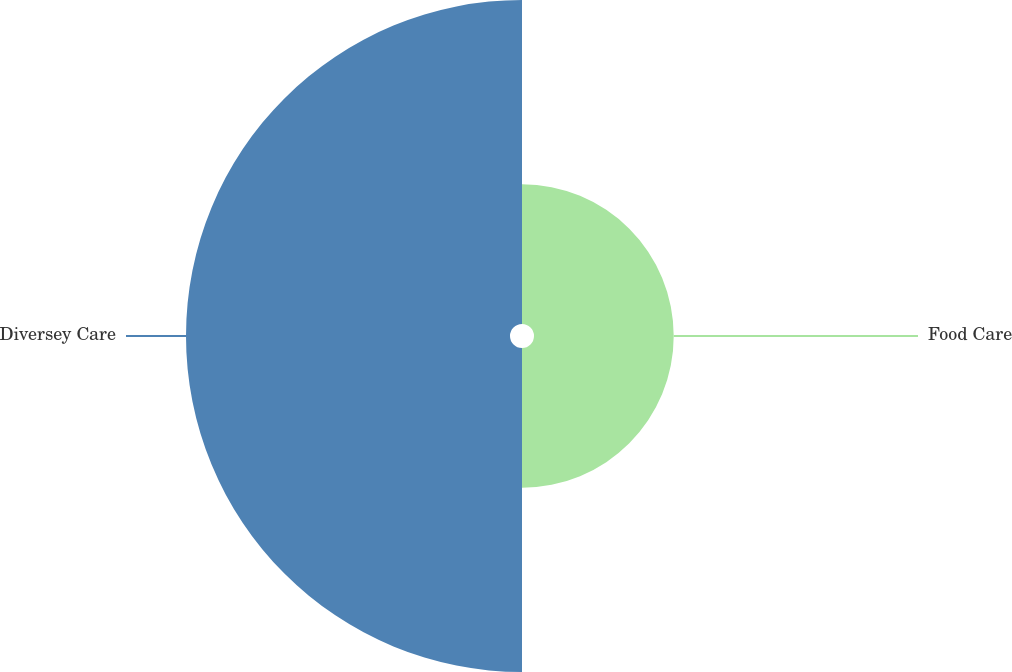<chart> <loc_0><loc_0><loc_500><loc_500><pie_chart><fcel>Food Care<fcel>Diversey Care<nl><fcel>30.13%<fcel>69.87%<nl></chart> 